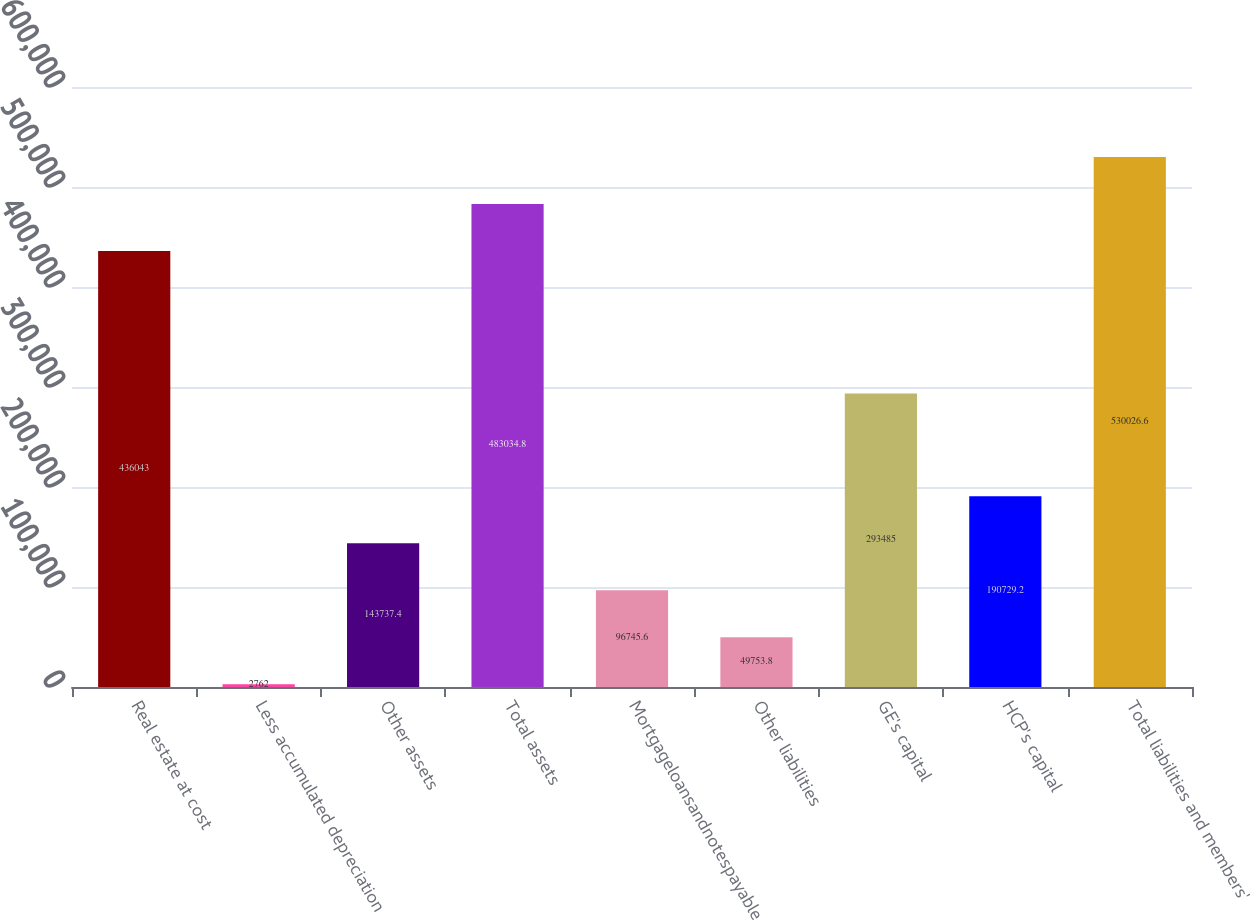<chart> <loc_0><loc_0><loc_500><loc_500><bar_chart><fcel>Real estate at cost<fcel>Less accumulated depreciation<fcel>Other assets<fcel>Total assets<fcel>Mortgageloansandnotespayable<fcel>Other liabilities<fcel>GE's capital<fcel>HCP's capital<fcel>Total liabilities and members'<nl><fcel>436043<fcel>2762<fcel>143737<fcel>483035<fcel>96745.6<fcel>49753.8<fcel>293485<fcel>190729<fcel>530027<nl></chart> 